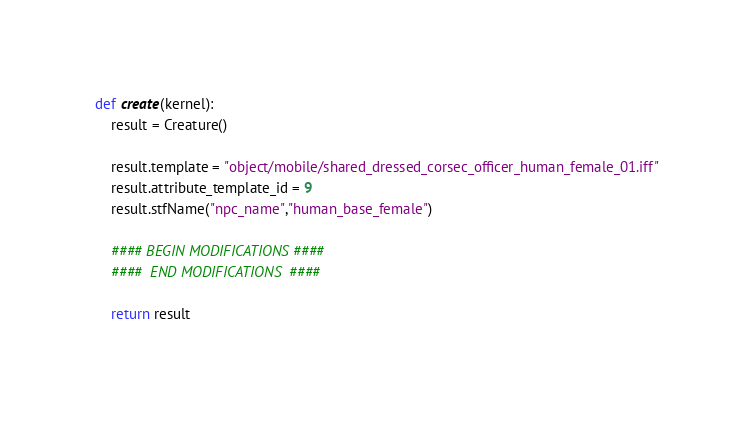Convert code to text. <code><loc_0><loc_0><loc_500><loc_500><_Python_>
def create(kernel):
	result = Creature()

	result.template = "object/mobile/shared_dressed_corsec_officer_human_female_01.iff"
	result.attribute_template_id = 9
	result.stfName("npc_name","human_base_female")		
	
	#### BEGIN MODIFICATIONS ####
	####  END MODIFICATIONS  ####
	
	return result</code> 